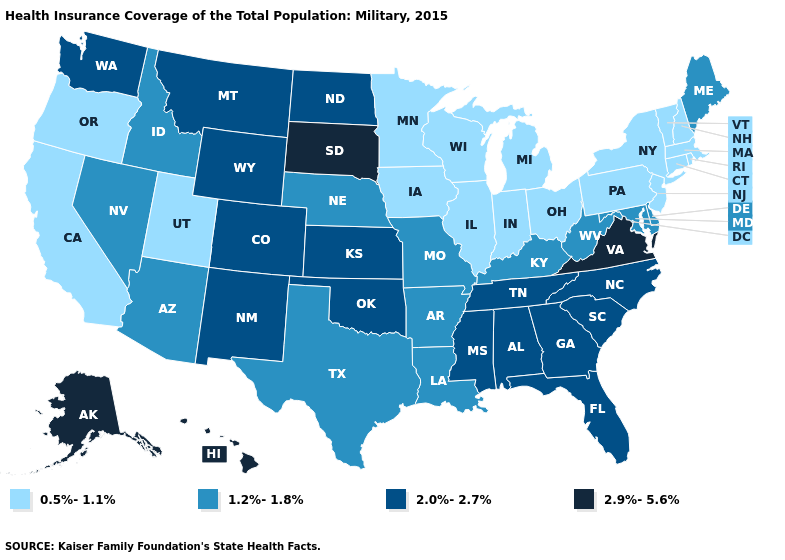Which states have the lowest value in the MidWest?
Be succinct. Illinois, Indiana, Iowa, Michigan, Minnesota, Ohio, Wisconsin. Does Montana have a higher value than Hawaii?
Give a very brief answer. No. What is the lowest value in the Northeast?
Concise answer only. 0.5%-1.1%. Name the states that have a value in the range 2.0%-2.7%?
Write a very short answer. Alabama, Colorado, Florida, Georgia, Kansas, Mississippi, Montana, New Mexico, North Carolina, North Dakota, Oklahoma, South Carolina, Tennessee, Washington, Wyoming. What is the highest value in the South ?
Keep it brief. 2.9%-5.6%. What is the value of Connecticut?
Short answer required. 0.5%-1.1%. What is the value of Mississippi?
Short answer required. 2.0%-2.7%. Does Rhode Island have the lowest value in the Northeast?
Write a very short answer. Yes. Does Maryland have the lowest value in the South?
Quick response, please. Yes. Does Massachusetts have a higher value than Florida?
Concise answer only. No. Does Iowa have the lowest value in the USA?
Answer briefly. Yes. Among the states that border South Dakota , does North Dakota have the highest value?
Give a very brief answer. Yes. Name the states that have a value in the range 0.5%-1.1%?
Answer briefly. California, Connecticut, Illinois, Indiana, Iowa, Massachusetts, Michigan, Minnesota, New Hampshire, New Jersey, New York, Ohio, Oregon, Pennsylvania, Rhode Island, Utah, Vermont, Wisconsin. What is the value of Alaska?
Be succinct. 2.9%-5.6%. Which states hav the highest value in the West?
Write a very short answer. Alaska, Hawaii. 